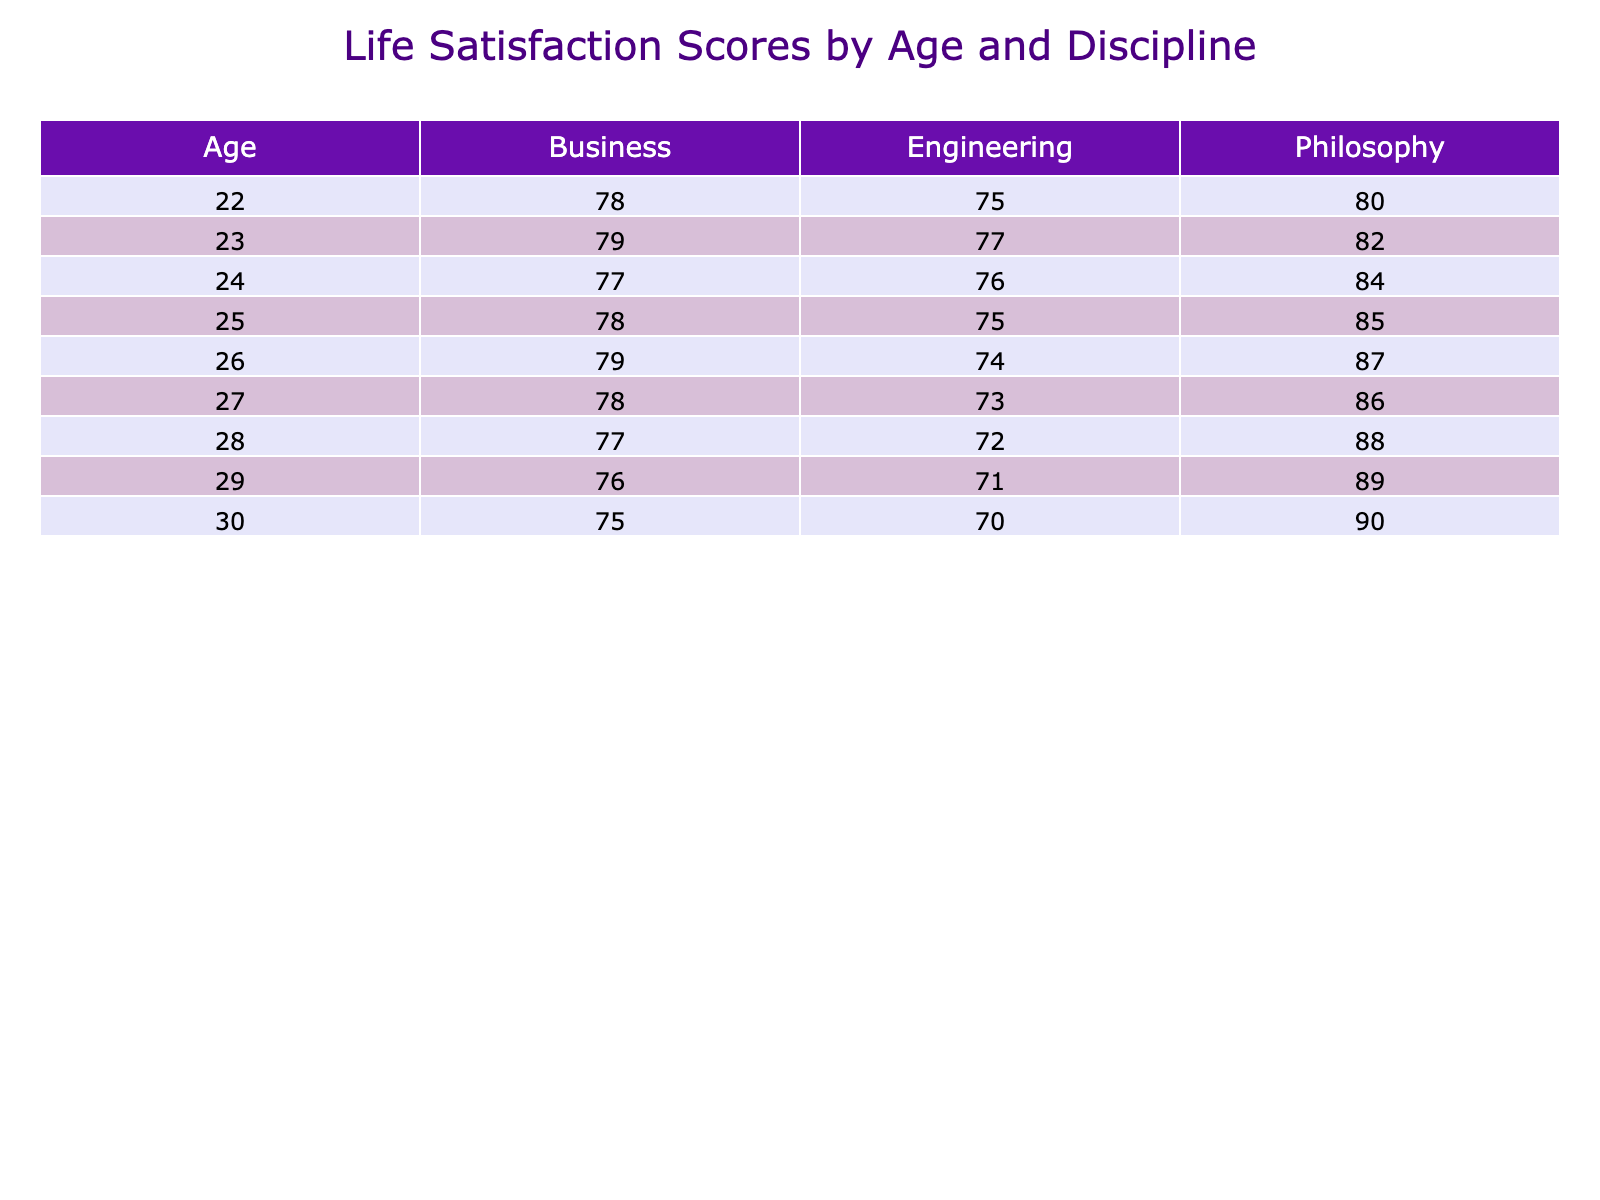What is the life satisfaction score for philosophy graduates at age 24? The table shows that at age 24, the life satisfaction score for philosophy graduates is 84.
Answer: 84 What is the life satisfaction score for engineering graduates at age 27? According to the table, the life satisfaction score for engineering graduates at age 27 is 73.
Answer: 73 What is the difference in life satisfaction between philosophy and business graduates at age 28? At age 28, philosophy graduates have a life satisfaction score of 88, while business graduates have a score of 77. The difference is 88 - 77 = 11.
Answer: 11 What is the average life satisfaction score for engineering graduates across all ages in the table? The scores for engineering graduates across ages are 75, 77, 76, 75, 74, 73, 72, 71, 70. Adding these scores gives 75 + 77 + 76 + 75 + 74 + 73 + 72 + 71 + 70 = 718. There are 9 scores, so the average is 718 / 9 ≈ 79.78.
Answer: Approximately 79.78 In which year did philosophy graduates first achieve a life satisfaction score of 86 or higher? The table indicates that philosophy graduates first achieved a score of 86 in 2025 when they were aged 27.
Answer: 2025 Do business graduates have a higher life satisfaction score than engineering graduates at age 24? From the table at age 24, business graduates have a score of 77 while engineering graduates have a score of 76. Since 77 > 76, the answer is yes.
Answer: Yes What is the trend in life satisfaction scores for philosophy graduates from age 22 to age 30? By examining the table, at age 22 the score was 80, and it continuously increased each subsequent year to reach 90 at age 30. This shows a positive trend in life satisfaction for philosophy graduates.
Answer: Positive trend Which discipline has the lowest life satisfaction score at age 26? Looking at the table, at age 26, engineering graduates have the lowest score of 74 compared to philosophy (87) and business (79).
Answer: Engineering 